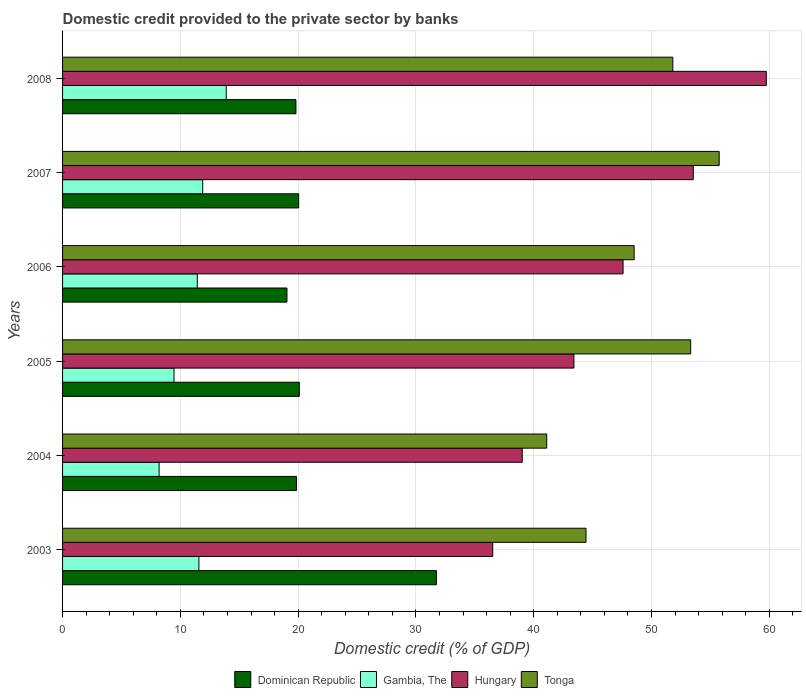How many different coloured bars are there?
Ensure brevity in your answer.  4. How many groups of bars are there?
Your response must be concise. 6. Are the number of bars per tick equal to the number of legend labels?
Keep it short and to the point. Yes. Are the number of bars on each tick of the Y-axis equal?
Your response must be concise. Yes. How many bars are there on the 1st tick from the bottom?
Your answer should be compact. 4. In how many cases, is the number of bars for a given year not equal to the number of legend labels?
Make the answer very short. 0. What is the domestic credit provided to the private sector by banks in Hungary in 2006?
Ensure brevity in your answer.  47.59. Across all years, what is the maximum domestic credit provided to the private sector by banks in Tonga?
Provide a short and direct response. 55.75. Across all years, what is the minimum domestic credit provided to the private sector by banks in Gambia, The?
Your answer should be compact. 8.2. In which year was the domestic credit provided to the private sector by banks in Gambia, The minimum?
Your response must be concise. 2004. What is the total domestic credit provided to the private sector by banks in Hungary in the graph?
Your answer should be compact. 279.86. What is the difference between the domestic credit provided to the private sector by banks in Hungary in 2006 and that in 2007?
Give a very brief answer. -5.96. What is the difference between the domestic credit provided to the private sector by banks in Gambia, The in 2005 and the domestic credit provided to the private sector by banks in Hungary in 2007?
Ensure brevity in your answer.  -44.09. What is the average domestic credit provided to the private sector by banks in Hungary per year?
Your answer should be very brief. 46.64. In the year 2008, what is the difference between the domestic credit provided to the private sector by banks in Hungary and domestic credit provided to the private sector by banks in Gambia, The?
Ensure brevity in your answer.  45.86. In how many years, is the domestic credit provided to the private sector by banks in Hungary greater than 42 %?
Give a very brief answer. 4. What is the ratio of the domestic credit provided to the private sector by banks in Dominican Republic in 2007 to that in 2008?
Make the answer very short. 1.01. Is the domestic credit provided to the private sector by banks in Gambia, The in 2003 less than that in 2004?
Offer a terse response. No. What is the difference between the highest and the second highest domestic credit provided to the private sector by banks in Tonga?
Your answer should be compact. 2.42. What is the difference between the highest and the lowest domestic credit provided to the private sector by banks in Hungary?
Your answer should be compact. 23.23. In how many years, is the domestic credit provided to the private sector by banks in Tonga greater than the average domestic credit provided to the private sector by banks in Tonga taken over all years?
Your answer should be very brief. 3. Is it the case that in every year, the sum of the domestic credit provided to the private sector by banks in Hungary and domestic credit provided to the private sector by banks in Gambia, The is greater than the sum of domestic credit provided to the private sector by banks in Dominican Republic and domestic credit provided to the private sector by banks in Tonga?
Provide a succinct answer. Yes. What does the 2nd bar from the top in 2003 represents?
Your answer should be compact. Hungary. What does the 2nd bar from the bottom in 2005 represents?
Provide a succinct answer. Gambia, The. How many years are there in the graph?
Offer a terse response. 6. Are the values on the major ticks of X-axis written in scientific E-notation?
Give a very brief answer. No. Does the graph contain grids?
Offer a very short reply. Yes. How many legend labels are there?
Your answer should be compact. 4. What is the title of the graph?
Your answer should be very brief. Domestic credit provided to the private sector by banks. Does "Zambia" appear as one of the legend labels in the graph?
Keep it short and to the point. No. What is the label or title of the X-axis?
Make the answer very short. Domestic credit (% of GDP). What is the Domestic credit (% of GDP) of Dominican Republic in 2003?
Provide a short and direct response. 31.74. What is the Domestic credit (% of GDP) of Gambia, The in 2003?
Provide a short and direct response. 11.58. What is the Domestic credit (% of GDP) in Hungary in 2003?
Your answer should be compact. 36.52. What is the Domestic credit (% of GDP) in Tonga in 2003?
Your answer should be very brief. 44.44. What is the Domestic credit (% of GDP) of Dominican Republic in 2004?
Keep it short and to the point. 19.86. What is the Domestic credit (% of GDP) in Gambia, The in 2004?
Give a very brief answer. 8.2. What is the Domestic credit (% of GDP) of Hungary in 2004?
Your answer should be very brief. 39.03. What is the Domestic credit (% of GDP) in Tonga in 2004?
Ensure brevity in your answer.  41.11. What is the Domestic credit (% of GDP) in Dominican Republic in 2005?
Keep it short and to the point. 20.1. What is the Domestic credit (% of GDP) of Gambia, The in 2005?
Offer a terse response. 9.46. What is the Domestic credit (% of GDP) of Hungary in 2005?
Offer a very short reply. 43.42. What is the Domestic credit (% of GDP) of Tonga in 2005?
Your answer should be compact. 53.33. What is the Domestic credit (% of GDP) of Dominican Republic in 2006?
Make the answer very short. 19.05. What is the Domestic credit (% of GDP) in Gambia, The in 2006?
Ensure brevity in your answer.  11.44. What is the Domestic credit (% of GDP) of Hungary in 2006?
Give a very brief answer. 47.59. What is the Domestic credit (% of GDP) in Tonga in 2006?
Provide a succinct answer. 48.53. What is the Domestic credit (% of GDP) in Dominican Republic in 2007?
Offer a terse response. 20.05. What is the Domestic credit (% of GDP) of Gambia, The in 2007?
Provide a succinct answer. 11.9. What is the Domestic credit (% of GDP) of Hungary in 2007?
Provide a succinct answer. 53.55. What is the Domestic credit (% of GDP) of Tonga in 2007?
Your answer should be very brief. 55.75. What is the Domestic credit (% of GDP) in Dominican Republic in 2008?
Make the answer very short. 19.81. What is the Domestic credit (% of GDP) of Gambia, The in 2008?
Offer a terse response. 13.9. What is the Domestic credit (% of GDP) in Hungary in 2008?
Offer a terse response. 59.75. What is the Domestic credit (% of GDP) in Tonga in 2008?
Give a very brief answer. 51.81. Across all years, what is the maximum Domestic credit (% of GDP) of Dominican Republic?
Offer a very short reply. 31.74. Across all years, what is the maximum Domestic credit (% of GDP) in Gambia, The?
Offer a very short reply. 13.9. Across all years, what is the maximum Domestic credit (% of GDP) of Hungary?
Your answer should be very brief. 59.75. Across all years, what is the maximum Domestic credit (% of GDP) in Tonga?
Offer a terse response. 55.75. Across all years, what is the minimum Domestic credit (% of GDP) in Dominican Republic?
Provide a short and direct response. 19.05. Across all years, what is the minimum Domestic credit (% of GDP) in Gambia, The?
Keep it short and to the point. 8.2. Across all years, what is the minimum Domestic credit (% of GDP) of Hungary?
Provide a short and direct response. 36.52. Across all years, what is the minimum Domestic credit (% of GDP) in Tonga?
Make the answer very short. 41.11. What is the total Domestic credit (% of GDP) of Dominican Republic in the graph?
Keep it short and to the point. 130.62. What is the total Domestic credit (% of GDP) of Gambia, The in the graph?
Offer a very short reply. 66.47. What is the total Domestic credit (% of GDP) in Hungary in the graph?
Offer a terse response. 279.86. What is the total Domestic credit (% of GDP) of Tonga in the graph?
Provide a succinct answer. 294.97. What is the difference between the Domestic credit (% of GDP) in Dominican Republic in 2003 and that in 2004?
Give a very brief answer. 11.88. What is the difference between the Domestic credit (% of GDP) in Gambia, The in 2003 and that in 2004?
Ensure brevity in your answer.  3.38. What is the difference between the Domestic credit (% of GDP) in Hungary in 2003 and that in 2004?
Your answer should be compact. -2.5. What is the difference between the Domestic credit (% of GDP) of Tonga in 2003 and that in 2004?
Ensure brevity in your answer.  3.34. What is the difference between the Domestic credit (% of GDP) in Dominican Republic in 2003 and that in 2005?
Keep it short and to the point. 11.64. What is the difference between the Domestic credit (% of GDP) in Gambia, The in 2003 and that in 2005?
Your answer should be very brief. 2.11. What is the difference between the Domestic credit (% of GDP) in Hungary in 2003 and that in 2005?
Provide a short and direct response. -6.89. What is the difference between the Domestic credit (% of GDP) of Tonga in 2003 and that in 2005?
Give a very brief answer. -8.88. What is the difference between the Domestic credit (% of GDP) of Dominican Republic in 2003 and that in 2006?
Your answer should be compact. 12.69. What is the difference between the Domestic credit (% of GDP) of Gambia, The in 2003 and that in 2006?
Keep it short and to the point. 0.14. What is the difference between the Domestic credit (% of GDP) in Hungary in 2003 and that in 2006?
Your response must be concise. -11.07. What is the difference between the Domestic credit (% of GDP) in Tonga in 2003 and that in 2006?
Your answer should be very brief. -4.09. What is the difference between the Domestic credit (% of GDP) in Dominican Republic in 2003 and that in 2007?
Your answer should be very brief. 11.69. What is the difference between the Domestic credit (% of GDP) in Gambia, The in 2003 and that in 2007?
Offer a very short reply. -0.32. What is the difference between the Domestic credit (% of GDP) of Hungary in 2003 and that in 2007?
Ensure brevity in your answer.  -17.03. What is the difference between the Domestic credit (% of GDP) of Tonga in 2003 and that in 2007?
Make the answer very short. -11.31. What is the difference between the Domestic credit (% of GDP) of Dominican Republic in 2003 and that in 2008?
Your response must be concise. 11.93. What is the difference between the Domestic credit (% of GDP) in Gambia, The in 2003 and that in 2008?
Your response must be concise. -2.32. What is the difference between the Domestic credit (% of GDP) in Hungary in 2003 and that in 2008?
Ensure brevity in your answer.  -23.23. What is the difference between the Domestic credit (% of GDP) of Tonga in 2003 and that in 2008?
Provide a succinct answer. -7.37. What is the difference between the Domestic credit (% of GDP) in Dominican Republic in 2004 and that in 2005?
Give a very brief answer. -0.24. What is the difference between the Domestic credit (% of GDP) of Gambia, The in 2004 and that in 2005?
Make the answer very short. -1.26. What is the difference between the Domestic credit (% of GDP) of Hungary in 2004 and that in 2005?
Ensure brevity in your answer.  -4.39. What is the difference between the Domestic credit (% of GDP) of Tonga in 2004 and that in 2005?
Your answer should be very brief. -12.22. What is the difference between the Domestic credit (% of GDP) in Dominican Republic in 2004 and that in 2006?
Provide a short and direct response. 0.81. What is the difference between the Domestic credit (% of GDP) in Gambia, The in 2004 and that in 2006?
Your answer should be very brief. -3.24. What is the difference between the Domestic credit (% of GDP) in Hungary in 2004 and that in 2006?
Give a very brief answer. -8.56. What is the difference between the Domestic credit (% of GDP) in Tonga in 2004 and that in 2006?
Your answer should be compact. -7.42. What is the difference between the Domestic credit (% of GDP) of Dominican Republic in 2004 and that in 2007?
Offer a terse response. -0.19. What is the difference between the Domestic credit (% of GDP) of Gambia, The in 2004 and that in 2007?
Make the answer very short. -3.7. What is the difference between the Domestic credit (% of GDP) in Hungary in 2004 and that in 2007?
Keep it short and to the point. -14.52. What is the difference between the Domestic credit (% of GDP) of Tonga in 2004 and that in 2007?
Your answer should be compact. -14.64. What is the difference between the Domestic credit (% of GDP) of Dominican Republic in 2004 and that in 2008?
Your answer should be compact. 0.05. What is the difference between the Domestic credit (% of GDP) of Gambia, The in 2004 and that in 2008?
Provide a succinct answer. -5.7. What is the difference between the Domestic credit (% of GDP) of Hungary in 2004 and that in 2008?
Offer a terse response. -20.72. What is the difference between the Domestic credit (% of GDP) of Tonga in 2004 and that in 2008?
Provide a short and direct response. -10.71. What is the difference between the Domestic credit (% of GDP) of Dominican Republic in 2005 and that in 2006?
Offer a terse response. 1.05. What is the difference between the Domestic credit (% of GDP) in Gambia, The in 2005 and that in 2006?
Provide a succinct answer. -1.98. What is the difference between the Domestic credit (% of GDP) in Hungary in 2005 and that in 2006?
Your answer should be very brief. -4.17. What is the difference between the Domestic credit (% of GDP) in Tonga in 2005 and that in 2006?
Give a very brief answer. 4.8. What is the difference between the Domestic credit (% of GDP) in Dominican Republic in 2005 and that in 2007?
Offer a very short reply. 0.05. What is the difference between the Domestic credit (% of GDP) in Gambia, The in 2005 and that in 2007?
Offer a very short reply. -2.44. What is the difference between the Domestic credit (% of GDP) in Hungary in 2005 and that in 2007?
Make the answer very short. -10.14. What is the difference between the Domestic credit (% of GDP) in Tonga in 2005 and that in 2007?
Provide a succinct answer. -2.42. What is the difference between the Domestic credit (% of GDP) of Dominican Republic in 2005 and that in 2008?
Keep it short and to the point. 0.29. What is the difference between the Domestic credit (% of GDP) in Gambia, The in 2005 and that in 2008?
Your response must be concise. -4.43. What is the difference between the Domestic credit (% of GDP) of Hungary in 2005 and that in 2008?
Your answer should be compact. -16.33. What is the difference between the Domestic credit (% of GDP) in Tonga in 2005 and that in 2008?
Provide a short and direct response. 1.51. What is the difference between the Domestic credit (% of GDP) of Dominican Republic in 2006 and that in 2007?
Give a very brief answer. -1. What is the difference between the Domestic credit (% of GDP) in Gambia, The in 2006 and that in 2007?
Your answer should be very brief. -0.46. What is the difference between the Domestic credit (% of GDP) of Hungary in 2006 and that in 2007?
Keep it short and to the point. -5.96. What is the difference between the Domestic credit (% of GDP) of Tonga in 2006 and that in 2007?
Provide a short and direct response. -7.22. What is the difference between the Domestic credit (% of GDP) of Dominican Republic in 2006 and that in 2008?
Provide a short and direct response. -0.76. What is the difference between the Domestic credit (% of GDP) of Gambia, The in 2006 and that in 2008?
Provide a succinct answer. -2.46. What is the difference between the Domestic credit (% of GDP) of Hungary in 2006 and that in 2008?
Keep it short and to the point. -12.16. What is the difference between the Domestic credit (% of GDP) of Tonga in 2006 and that in 2008?
Make the answer very short. -3.28. What is the difference between the Domestic credit (% of GDP) of Dominican Republic in 2007 and that in 2008?
Give a very brief answer. 0.23. What is the difference between the Domestic credit (% of GDP) in Gambia, The in 2007 and that in 2008?
Your answer should be very brief. -2. What is the difference between the Domestic credit (% of GDP) of Hungary in 2007 and that in 2008?
Keep it short and to the point. -6.2. What is the difference between the Domestic credit (% of GDP) in Tonga in 2007 and that in 2008?
Keep it short and to the point. 3.94. What is the difference between the Domestic credit (% of GDP) of Dominican Republic in 2003 and the Domestic credit (% of GDP) of Gambia, The in 2004?
Your answer should be very brief. 23.54. What is the difference between the Domestic credit (% of GDP) in Dominican Republic in 2003 and the Domestic credit (% of GDP) in Hungary in 2004?
Your response must be concise. -7.29. What is the difference between the Domestic credit (% of GDP) of Dominican Republic in 2003 and the Domestic credit (% of GDP) of Tonga in 2004?
Your response must be concise. -9.36. What is the difference between the Domestic credit (% of GDP) of Gambia, The in 2003 and the Domestic credit (% of GDP) of Hungary in 2004?
Give a very brief answer. -27.45. What is the difference between the Domestic credit (% of GDP) in Gambia, The in 2003 and the Domestic credit (% of GDP) in Tonga in 2004?
Your answer should be very brief. -29.53. What is the difference between the Domestic credit (% of GDP) of Hungary in 2003 and the Domestic credit (% of GDP) of Tonga in 2004?
Provide a succinct answer. -4.58. What is the difference between the Domestic credit (% of GDP) in Dominican Republic in 2003 and the Domestic credit (% of GDP) in Gambia, The in 2005?
Ensure brevity in your answer.  22.28. What is the difference between the Domestic credit (% of GDP) of Dominican Republic in 2003 and the Domestic credit (% of GDP) of Hungary in 2005?
Ensure brevity in your answer.  -11.68. What is the difference between the Domestic credit (% of GDP) of Dominican Republic in 2003 and the Domestic credit (% of GDP) of Tonga in 2005?
Provide a short and direct response. -21.59. What is the difference between the Domestic credit (% of GDP) in Gambia, The in 2003 and the Domestic credit (% of GDP) in Hungary in 2005?
Offer a very short reply. -31.84. What is the difference between the Domestic credit (% of GDP) of Gambia, The in 2003 and the Domestic credit (% of GDP) of Tonga in 2005?
Your answer should be compact. -41.75. What is the difference between the Domestic credit (% of GDP) of Hungary in 2003 and the Domestic credit (% of GDP) of Tonga in 2005?
Keep it short and to the point. -16.8. What is the difference between the Domestic credit (% of GDP) in Dominican Republic in 2003 and the Domestic credit (% of GDP) in Gambia, The in 2006?
Provide a short and direct response. 20.3. What is the difference between the Domestic credit (% of GDP) of Dominican Republic in 2003 and the Domestic credit (% of GDP) of Hungary in 2006?
Provide a succinct answer. -15.85. What is the difference between the Domestic credit (% of GDP) of Dominican Republic in 2003 and the Domestic credit (% of GDP) of Tonga in 2006?
Make the answer very short. -16.79. What is the difference between the Domestic credit (% of GDP) in Gambia, The in 2003 and the Domestic credit (% of GDP) in Hungary in 2006?
Provide a succinct answer. -36.01. What is the difference between the Domestic credit (% of GDP) in Gambia, The in 2003 and the Domestic credit (% of GDP) in Tonga in 2006?
Your response must be concise. -36.95. What is the difference between the Domestic credit (% of GDP) in Hungary in 2003 and the Domestic credit (% of GDP) in Tonga in 2006?
Make the answer very short. -12.01. What is the difference between the Domestic credit (% of GDP) in Dominican Republic in 2003 and the Domestic credit (% of GDP) in Gambia, The in 2007?
Your response must be concise. 19.84. What is the difference between the Domestic credit (% of GDP) in Dominican Republic in 2003 and the Domestic credit (% of GDP) in Hungary in 2007?
Give a very brief answer. -21.81. What is the difference between the Domestic credit (% of GDP) of Dominican Republic in 2003 and the Domestic credit (% of GDP) of Tonga in 2007?
Provide a short and direct response. -24.01. What is the difference between the Domestic credit (% of GDP) in Gambia, The in 2003 and the Domestic credit (% of GDP) in Hungary in 2007?
Keep it short and to the point. -41.98. What is the difference between the Domestic credit (% of GDP) of Gambia, The in 2003 and the Domestic credit (% of GDP) of Tonga in 2007?
Your answer should be very brief. -44.17. What is the difference between the Domestic credit (% of GDP) in Hungary in 2003 and the Domestic credit (% of GDP) in Tonga in 2007?
Provide a short and direct response. -19.23. What is the difference between the Domestic credit (% of GDP) of Dominican Republic in 2003 and the Domestic credit (% of GDP) of Gambia, The in 2008?
Your answer should be compact. 17.85. What is the difference between the Domestic credit (% of GDP) in Dominican Republic in 2003 and the Domestic credit (% of GDP) in Hungary in 2008?
Provide a succinct answer. -28.01. What is the difference between the Domestic credit (% of GDP) of Dominican Republic in 2003 and the Domestic credit (% of GDP) of Tonga in 2008?
Give a very brief answer. -20.07. What is the difference between the Domestic credit (% of GDP) of Gambia, The in 2003 and the Domestic credit (% of GDP) of Hungary in 2008?
Provide a succinct answer. -48.18. What is the difference between the Domestic credit (% of GDP) in Gambia, The in 2003 and the Domestic credit (% of GDP) in Tonga in 2008?
Ensure brevity in your answer.  -40.24. What is the difference between the Domestic credit (% of GDP) in Hungary in 2003 and the Domestic credit (% of GDP) in Tonga in 2008?
Make the answer very short. -15.29. What is the difference between the Domestic credit (% of GDP) in Dominican Republic in 2004 and the Domestic credit (% of GDP) in Gambia, The in 2005?
Provide a succinct answer. 10.4. What is the difference between the Domestic credit (% of GDP) in Dominican Republic in 2004 and the Domestic credit (% of GDP) in Hungary in 2005?
Your answer should be compact. -23.55. What is the difference between the Domestic credit (% of GDP) of Dominican Republic in 2004 and the Domestic credit (% of GDP) of Tonga in 2005?
Your response must be concise. -33.47. What is the difference between the Domestic credit (% of GDP) of Gambia, The in 2004 and the Domestic credit (% of GDP) of Hungary in 2005?
Your answer should be compact. -35.22. What is the difference between the Domestic credit (% of GDP) of Gambia, The in 2004 and the Domestic credit (% of GDP) of Tonga in 2005?
Offer a very short reply. -45.13. What is the difference between the Domestic credit (% of GDP) in Hungary in 2004 and the Domestic credit (% of GDP) in Tonga in 2005?
Ensure brevity in your answer.  -14.3. What is the difference between the Domestic credit (% of GDP) of Dominican Republic in 2004 and the Domestic credit (% of GDP) of Gambia, The in 2006?
Your answer should be compact. 8.42. What is the difference between the Domestic credit (% of GDP) of Dominican Republic in 2004 and the Domestic credit (% of GDP) of Hungary in 2006?
Keep it short and to the point. -27.73. What is the difference between the Domestic credit (% of GDP) in Dominican Republic in 2004 and the Domestic credit (% of GDP) in Tonga in 2006?
Offer a terse response. -28.67. What is the difference between the Domestic credit (% of GDP) of Gambia, The in 2004 and the Domestic credit (% of GDP) of Hungary in 2006?
Offer a very short reply. -39.39. What is the difference between the Domestic credit (% of GDP) in Gambia, The in 2004 and the Domestic credit (% of GDP) in Tonga in 2006?
Your answer should be very brief. -40.33. What is the difference between the Domestic credit (% of GDP) of Hungary in 2004 and the Domestic credit (% of GDP) of Tonga in 2006?
Provide a short and direct response. -9.5. What is the difference between the Domestic credit (% of GDP) in Dominican Republic in 2004 and the Domestic credit (% of GDP) in Gambia, The in 2007?
Give a very brief answer. 7.96. What is the difference between the Domestic credit (% of GDP) of Dominican Republic in 2004 and the Domestic credit (% of GDP) of Hungary in 2007?
Give a very brief answer. -33.69. What is the difference between the Domestic credit (% of GDP) of Dominican Republic in 2004 and the Domestic credit (% of GDP) of Tonga in 2007?
Make the answer very short. -35.89. What is the difference between the Domestic credit (% of GDP) in Gambia, The in 2004 and the Domestic credit (% of GDP) in Hungary in 2007?
Make the answer very short. -45.35. What is the difference between the Domestic credit (% of GDP) in Gambia, The in 2004 and the Domestic credit (% of GDP) in Tonga in 2007?
Make the answer very short. -47.55. What is the difference between the Domestic credit (% of GDP) of Hungary in 2004 and the Domestic credit (% of GDP) of Tonga in 2007?
Ensure brevity in your answer.  -16.72. What is the difference between the Domestic credit (% of GDP) of Dominican Republic in 2004 and the Domestic credit (% of GDP) of Gambia, The in 2008?
Make the answer very short. 5.97. What is the difference between the Domestic credit (% of GDP) of Dominican Republic in 2004 and the Domestic credit (% of GDP) of Hungary in 2008?
Ensure brevity in your answer.  -39.89. What is the difference between the Domestic credit (% of GDP) of Dominican Republic in 2004 and the Domestic credit (% of GDP) of Tonga in 2008?
Provide a succinct answer. -31.95. What is the difference between the Domestic credit (% of GDP) in Gambia, The in 2004 and the Domestic credit (% of GDP) in Hungary in 2008?
Provide a succinct answer. -51.55. What is the difference between the Domestic credit (% of GDP) of Gambia, The in 2004 and the Domestic credit (% of GDP) of Tonga in 2008?
Ensure brevity in your answer.  -43.62. What is the difference between the Domestic credit (% of GDP) in Hungary in 2004 and the Domestic credit (% of GDP) in Tonga in 2008?
Keep it short and to the point. -12.78. What is the difference between the Domestic credit (% of GDP) in Dominican Republic in 2005 and the Domestic credit (% of GDP) in Gambia, The in 2006?
Ensure brevity in your answer.  8.66. What is the difference between the Domestic credit (% of GDP) in Dominican Republic in 2005 and the Domestic credit (% of GDP) in Hungary in 2006?
Your answer should be very brief. -27.49. What is the difference between the Domestic credit (% of GDP) of Dominican Republic in 2005 and the Domestic credit (% of GDP) of Tonga in 2006?
Your answer should be compact. -28.43. What is the difference between the Domestic credit (% of GDP) of Gambia, The in 2005 and the Domestic credit (% of GDP) of Hungary in 2006?
Give a very brief answer. -38.13. What is the difference between the Domestic credit (% of GDP) in Gambia, The in 2005 and the Domestic credit (% of GDP) in Tonga in 2006?
Make the answer very short. -39.07. What is the difference between the Domestic credit (% of GDP) of Hungary in 2005 and the Domestic credit (% of GDP) of Tonga in 2006?
Your answer should be compact. -5.11. What is the difference between the Domestic credit (% of GDP) in Dominican Republic in 2005 and the Domestic credit (% of GDP) in Gambia, The in 2007?
Offer a terse response. 8.2. What is the difference between the Domestic credit (% of GDP) of Dominican Republic in 2005 and the Domestic credit (% of GDP) of Hungary in 2007?
Ensure brevity in your answer.  -33.45. What is the difference between the Domestic credit (% of GDP) in Dominican Republic in 2005 and the Domestic credit (% of GDP) in Tonga in 2007?
Give a very brief answer. -35.65. What is the difference between the Domestic credit (% of GDP) of Gambia, The in 2005 and the Domestic credit (% of GDP) of Hungary in 2007?
Your answer should be compact. -44.09. What is the difference between the Domestic credit (% of GDP) in Gambia, The in 2005 and the Domestic credit (% of GDP) in Tonga in 2007?
Ensure brevity in your answer.  -46.29. What is the difference between the Domestic credit (% of GDP) in Hungary in 2005 and the Domestic credit (% of GDP) in Tonga in 2007?
Make the answer very short. -12.33. What is the difference between the Domestic credit (% of GDP) in Dominican Republic in 2005 and the Domestic credit (% of GDP) in Gambia, The in 2008?
Your answer should be compact. 6.21. What is the difference between the Domestic credit (% of GDP) of Dominican Republic in 2005 and the Domestic credit (% of GDP) of Hungary in 2008?
Offer a very short reply. -39.65. What is the difference between the Domestic credit (% of GDP) in Dominican Republic in 2005 and the Domestic credit (% of GDP) in Tonga in 2008?
Your answer should be compact. -31.71. What is the difference between the Domestic credit (% of GDP) in Gambia, The in 2005 and the Domestic credit (% of GDP) in Hungary in 2008?
Offer a very short reply. -50.29. What is the difference between the Domestic credit (% of GDP) of Gambia, The in 2005 and the Domestic credit (% of GDP) of Tonga in 2008?
Your answer should be very brief. -42.35. What is the difference between the Domestic credit (% of GDP) in Hungary in 2005 and the Domestic credit (% of GDP) in Tonga in 2008?
Offer a very short reply. -8.4. What is the difference between the Domestic credit (% of GDP) in Dominican Republic in 2006 and the Domestic credit (% of GDP) in Gambia, The in 2007?
Ensure brevity in your answer.  7.15. What is the difference between the Domestic credit (% of GDP) of Dominican Republic in 2006 and the Domestic credit (% of GDP) of Hungary in 2007?
Provide a succinct answer. -34.5. What is the difference between the Domestic credit (% of GDP) in Dominican Republic in 2006 and the Domestic credit (% of GDP) in Tonga in 2007?
Offer a very short reply. -36.7. What is the difference between the Domestic credit (% of GDP) in Gambia, The in 2006 and the Domestic credit (% of GDP) in Hungary in 2007?
Your answer should be very brief. -42.11. What is the difference between the Domestic credit (% of GDP) in Gambia, The in 2006 and the Domestic credit (% of GDP) in Tonga in 2007?
Your answer should be very brief. -44.31. What is the difference between the Domestic credit (% of GDP) of Hungary in 2006 and the Domestic credit (% of GDP) of Tonga in 2007?
Provide a succinct answer. -8.16. What is the difference between the Domestic credit (% of GDP) in Dominican Republic in 2006 and the Domestic credit (% of GDP) in Gambia, The in 2008?
Your answer should be compact. 5.16. What is the difference between the Domestic credit (% of GDP) in Dominican Republic in 2006 and the Domestic credit (% of GDP) in Hungary in 2008?
Your response must be concise. -40.7. What is the difference between the Domestic credit (% of GDP) in Dominican Republic in 2006 and the Domestic credit (% of GDP) in Tonga in 2008?
Offer a very short reply. -32.76. What is the difference between the Domestic credit (% of GDP) of Gambia, The in 2006 and the Domestic credit (% of GDP) of Hungary in 2008?
Provide a short and direct response. -48.31. What is the difference between the Domestic credit (% of GDP) in Gambia, The in 2006 and the Domestic credit (% of GDP) in Tonga in 2008?
Provide a succinct answer. -40.37. What is the difference between the Domestic credit (% of GDP) in Hungary in 2006 and the Domestic credit (% of GDP) in Tonga in 2008?
Ensure brevity in your answer.  -4.22. What is the difference between the Domestic credit (% of GDP) in Dominican Republic in 2007 and the Domestic credit (% of GDP) in Gambia, The in 2008?
Offer a terse response. 6.15. What is the difference between the Domestic credit (% of GDP) in Dominican Republic in 2007 and the Domestic credit (% of GDP) in Hungary in 2008?
Ensure brevity in your answer.  -39.7. What is the difference between the Domestic credit (% of GDP) in Dominican Republic in 2007 and the Domestic credit (% of GDP) in Tonga in 2008?
Your answer should be very brief. -31.77. What is the difference between the Domestic credit (% of GDP) of Gambia, The in 2007 and the Domestic credit (% of GDP) of Hungary in 2008?
Offer a terse response. -47.85. What is the difference between the Domestic credit (% of GDP) in Gambia, The in 2007 and the Domestic credit (% of GDP) in Tonga in 2008?
Offer a terse response. -39.92. What is the difference between the Domestic credit (% of GDP) of Hungary in 2007 and the Domestic credit (% of GDP) of Tonga in 2008?
Give a very brief answer. 1.74. What is the average Domestic credit (% of GDP) of Dominican Republic per year?
Provide a short and direct response. 21.77. What is the average Domestic credit (% of GDP) in Gambia, The per year?
Provide a short and direct response. 11.08. What is the average Domestic credit (% of GDP) in Hungary per year?
Keep it short and to the point. 46.64. What is the average Domestic credit (% of GDP) of Tonga per year?
Provide a succinct answer. 49.16. In the year 2003, what is the difference between the Domestic credit (% of GDP) of Dominican Republic and Domestic credit (% of GDP) of Gambia, The?
Make the answer very short. 20.17. In the year 2003, what is the difference between the Domestic credit (% of GDP) of Dominican Republic and Domestic credit (% of GDP) of Hungary?
Make the answer very short. -4.78. In the year 2003, what is the difference between the Domestic credit (% of GDP) in Dominican Republic and Domestic credit (% of GDP) in Tonga?
Make the answer very short. -12.7. In the year 2003, what is the difference between the Domestic credit (% of GDP) in Gambia, The and Domestic credit (% of GDP) in Hungary?
Make the answer very short. -24.95. In the year 2003, what is the difference between the Domestic credit (% of GDP) of Gambia, The and Domestic credit (% of GDP) of Tonga?
Keep it short and to the point. -32.87. In the year 2003, what is the difference between the Domestic credit (% of GDP) of Hungary and Domestic credit (% of GDP) of Tonga?
Provide a short and direct response. -7.92. In the year 2004, what is the difference between the Domestic credit (% of GDP) of Dominican Republic and Domestic credit (% of GDP) of Gambia, The?
Make the answer very short. 11.66. In the year 2004, what is the difference between the Domestic credit (% of GDP) of Dominican Republic and Domestic credit (% of GDP) of Hungary?
Offer a terse response. -19.17. In the year 2004, what is the difference between the Domestic credit (% of GDP) in Dominican Republic and Domestic credit (% of GDP) in Tonga?
Offer a terse response. -21.24. In the year 2004, what is the difference between the Domestic credit (% of GDP) of Gambia, The and Domestic credit (% of GDP) of Hungary?
Provide a short and direct response. -30.83. In the year 2004, what is the difference between the Domestic credit (% of GDP) in Gambia, The and Domestic credit (% of GDP) in Tonga?
Your answer should be compact. -32.91. In the year 2004, what is the difference between the Domestic credit (% of GDP) in Hungary and Domestic credit (% of GDP) in Tonga?
Your answer should be very brief. -2.08. In the year 2005, what is the difference between the Domestic credit (% of GDP) of Dominican Republic and Domestic credit (% of GDP) of Gambia, The?
Your answer should be compact. 10.64. In the year 2005, what is the difference between the Domestic credit (% of GDP) of Dominican Republic and Domestic credit (% of GDP) of Hungary?
Your answer should be compact. -23.31. In the year 2005, what is the difference between the Domestic credit (% of GDP) in Dominican Republic and Domestic credit (% of GDP) in Tonga?
Make the answer very short. -33.23. In the year 2005, what is the difference between the Domestic credit (% of GDP) in Gambia, The and Domestic credit (% of GDP) in Hungary?
Provide a short and direct response. -33.95. In the year 2005, what is the difference between the Domestic credit (% of GDP) in Gambia, The and Domestic credit (% of GDP) in Tonga?
Your response must be concise. -43.87. In the year 2005, what is the difference between the Domestic credit (% of GDP) in Hungary and Domestic credit (% of GDP) in Tonga?
Keep it short and to the point. -9.91. In the year 2006, what is the difference between the Domestic credit (% of GDP) in Dominican Republic and Domestic credit (% of GDP) in Gambia, The?
Ensure brevity in your answer.  7.61. In the year 2006, what is the difference between the Domestic credit (% of GDP) of Dominican Republic and Domestic credit (% of GDP) of Hungary?
Give a very brief answer. -28.54. In the year 2006, what is the difference between the Domestic credit (% of GDP) of Dominican Republic and Domestic credit (% of GDP) of Tonga?
Give a very brief answer. -29.48. In the year 2006, what is the difference between the Domestic credit (% of GDP) of Gambia, The and Domestic credit (% of GDP) of Hungary?
Provide a short and direct response. -36.15. In the year 2006, what is the difference between the Domestic credit (% of GDP) of Gambia, The and Domestic credit (% of GDP) of Tonga?
Offer a terse response. -37.09. In the year 2006, what is the difference between the Domestic credit (% of GDP) of Hungary and Domestic credit (% of GDP) of Tonga?
Offer a terse response. -0.94. In the year 2007, what is the difference between the Domestic credit (% of GDP) of Dominican Republic and Domestic credit (% of GDP) of Gambia, The?
Provide a short and direct response. 8.15. In the year 2007, what is the difference between the Domestic credit (% of GDP) of Dominican Republic and Domestic credit (% of GDP) of Hungary?
Keep it short and to the point. -33.5. In the year 2007, what is the difference between the Domestic credit (% of GDP) of Dominican Republic and Domestic credit (% of GDP) of Tonga?
Keep it short and to the point. -35.7. In the year 2007, what is the difference between the Domestic credit (% of GDP) in Gambia, The and Domestic credit (% of GDP) in Hungary?
Your answer should be compact. -41.65. In the year 2007, what is the difference between the Domestic credit (% of GDP) of Gambia, The and Domestic credit (% of GDP) of Tonga?
Your answer should be compact. -43.85. In the year 2007, what is the difference between the Domestic credit (% of GDP) of Hungary and Domestic credit (% of GDP) of Tonga?
Offer a terse response. -2.2. In the year 2008, what is the difference between the Domestic credit (% of GDP) of Dominican Republic and Domestic credit (% of GDP) of Gambia, The?
Offer a very short reply. 5.92. In the year 2008, what is the difference between the Domestic credit (% of GDP) of Dominican Republic and Domestic credit (% of GDP) of Hungary?
Make the answer very short. -39.94. In the year 2008, what is the difference between the Domestic credit (% of GDP) in Dominican Republic and Domestic credit (% of GDP) in Tonga?
Offer a terse response. -32. In the year 2008, what is the difference between the Domestic credit (% of GDP) of Gambia, The and Domestic credit (% of GDP) of Hungary?
Make the answer very short. -45.85. In the year 2008, what is the difference between the Domestic credit (% of GDP) in Gambia, The and Domestic credit (% of GDP) in Tonga?
Your answer should be compact. -37.92. In the year 2008, what is the difference between the Domestic credit (% of GDP) of Hungary and Domestic credit (% of GDP) of Tonga?
Your answer should be compact. 7.94. What is the ratio of the Domestic credit (% of GDP) in Dominican Republic in 2003 to that in 2004?
Offer a very short reply. 1.6. What is the ratio of the Domestic credit (% of GDP) of Gambia, The in 2003 to that in 2004?
Ensure brevity in your answer.  1.41. What is the ratio of the Domestic credit (% of GDP) in Hungary in 2003 to that in 2004?
Provide a succinct answer. 0.94. What is the ratio of the Domestic credit (% of GDP) in Tonga in 2003 to that in 2004?
Give a very brief answer. 1.08. What is the ratio of the Domestic credit (% of GDP) of Dominican Republic in 2003 to that in 2005?
Your answer should be compact. 1.58. What is the ratio of the Domestic credit (% of GDP) in Gambia, The in 2003 to that in 2005?
Give a very brief answer. 1.22. What is the ratio of the Domestic credit (% of GDP) in Hungary in 2003 to that in 2005?
Make the answer very short. 0.84. What is the ratio of the Domestic credit (% of GDP) of Tonga in 2003 to that in 2005?
Ensure brevity in your answer.  0.83. What is the ratio of the Domestic credit (% of GDP) of Dominican Republic in 2003 to that in 2006?
Give a very brief answer. 1.67. What is the ratio of the Domestic credit (% of GDP) in Gambia, The in 2003 to that in 2006?
Offer a terse response. 1.01. What is the ratio of the Domestic credit (% of GDP) of Hungary in 2003 to that in 2006?
Offer a terse response. 0.77. What is the ratio of the Domestic credit (% of GDP) of Tonga in 2003 to that in 2006?
Your answer should be very brief. 0.92. What is the ratio of the Domestic credit (% of GDP) of Dominican Republic in 2003 to that in 2007?
Ensure brevity in your answer.  1.58. What is the ratio of the Domestic credit (% of GDP) in Gambia, The in 2003 to that in 2007?
Make the answer very short. 0.97. What is the ratio of the Domestic credit (% of GDP) in Hungary in 2003 to that in 2007?
Give a very brief answer. 0.68. What is the ratio of the Domestic credit (% of GDP) of Tonga in 2003 to that in 2007?
Keep it short and to the point. 0.8. What is the ratio of the Domestic credit (% of GDP) in Dominican Republic in 2003 to that in 2008?
Your response must be concise. 1.6. What is the ratio of the Domestic credit (% of GDP) of Gambia, The in 2003 to that in 2008?
Your answer should be compact. 0.83. What is the ratio of the Domestic credit (% of GDP) of Hungary in 2003 to that in 2008?
Provide a succinct answer. 0.61. What is the ratio of the Domestic credit (% of GDP) in Tonga in 2003 to that in 2008?
Your answer should be very brief. 0.86. What is the ratio of the Domestic credit (% of GDP) of Gambia, The in 2004 to that in 2005?
Your answer should be compact. 0.87. What is the ratio of the Domestic credit (% of GDP) in Hungary in 2004 to that in 2005?
Your answer should be compact. 0.9. What is the ratio of the Domestic credit (% of GDP) of Tonga in 2004 to that in 2005?
Keep it short and to the point. 0.77. What is the ratio of the Domestic credit (% of GDP) of Dominican Republic in 2004 to that in 2006?
Offer a terse response. 1.04. What is the ratio of the Domestic credit (% of GDP) of Gambia, The in 2004 to that in 2006?
Make the answer very short. 0.72. What is the ratio of the Domestic credit (% of GDP) of Hungary in 2004 to that in 2006?
Offer a terse response. 0.82. What is the ratio of the Domestic credit (% of GDP) of Tonga in 2004 to that in 2006?
Provide a succinct answer. 0.85. What is the ratio of the Domestic credit (% of GDP) of Gambia, The in 2004 to that in 2007?
Your answer should be very brief. 0.69. What is the ratio of the Domestic credit (% of GDP) of Hungary in 2004 to that in 2007?
Make the answer very short. 0.73. What is the ratio of the Domestic credit (% of GDP) in Tonga in 2004 to that in 2007?
Your response must be concise. 0.74. What is the ratio of the Domestic credit (% of GDP) of Dominican Republic in 2004 to that in 2008?
Provide a succinct answer. 1. What is the ratio of the Domestic credit (% of GDP) of Gambia, The in 2004 to that in 2008?
Your answer should be compact. 0.59. What is the ratio of the Domestic credit (% of GDP) of Hungary in 2004 to that in 2008?
Ensure brevity in your answer.  0.65. What is the ratio of the Domestic credit (% of GDP) in Tonga in 2004 to that in 2008?
Ensure brevity in your answer.  0.79. What is the ratio of the Domestic credit (% of GDP) of Dominican Republic in 2005 to that in 2006?
Provide a succinct answer. 1.06. What is the ratio of the Domestic credit (% of GDP) of Gambia, The in 2005 to that in 2006?
Your answer should be compact. 0.83. What is the ratio of the Domestic credit (% of GDP) of Hungary in 2005 to that in 2006?
Your answer should be very brief. 0.91. What is the ratio of the Domestic credit (% of GDP) of Tonga in 2005 to that in 2006?
Your answer should be compact. 1.1. What is the ratio of the Domestic credit (% of GDP) in Gambia, The in 2005 to that in 2007?
Offer a terse response. 0.8. What is the ratio of the Domestic credit (% of GDP) in Hungary in 2005 to that in 2007?
Give a very brief answer. 0.81. What is the ratio of the Domestic credit (% of GDP) in Tonga in 2005 to that in 2007?
Your answer should be very brief. 0.96. What is the ratio of the Domestic credit (% of GDP) in Dominican Republic in 2005 to that in 2008?
Give a very brief answer. 1.01. What is the ratio of the Domestic credit (% of GDP) in Gambia, The in 2005 to that in 2008?
Offer a very short reply. 0.68. What is the ratio of the Domestic credit (% of GDP) in Hungary in 2005 to that in 2008?
Provide a short and direct response. 0.73. What is the ratio of the Domestic credit (% of GDP) in Tonga in 2005 to that in 2008?
Make the answer very short. 1.03. What is the ratio of the Domestic credit (% of GDP) in Dominican Republic in 2006 to that in 2007?
Provide a succinct answer. 0.95. What is the ratio of the Domestic credit (% of GDP) of Gambia, The in 2006 to that in 2007?
Keep it short and to the point. 0.96. What is the ratio of the Domestic credit (% of GDP) in Hungary in 2006 to that in 2007?
Your response must be concise. 0.89. What is the ratio of the Domestic credit (% of GDP) in Tonga in 2006 to that in 2007?
Your answer should be compact. 0.87. What is the ratio of the Domestic credit (% of GDP) of Dominican Republic in 2006 to that in 2008?
Ensure brevity in your answer.  0.96. What is the ratio of the Domestic credit (% of GDP) in Gambia, The in 2006 to that in 2008?
Make the answer very short. 0.82. What is the ratio of the Domestic credit (% of GDP) of Hungary in 2006 to that in 2008?
Ensure brevity in your answer.  0.8. What is the ratio of the Domestic credit (% of GDP) in Tonga in 2006 to that in 2008?
Your response must be concise. 0.94. What is the ratio of the Domestic credit (% of GDP) in Dominican Republic in 2007 to that in 2008?
Make the answer very short. 1.01. What is the ratio of the Domestic credit (% of GDP) of Gambia, The in 2007 to that in 2008?
Offer a very short reply. 0.86. What is the ratio of the Domestic credit (% of GDP) in Hungary in 2007 to that in 2008?
Your answer should be very brief. 0.9. What is the ratio of the Domestic credit (% of GDP) of Tonga in 2007 to that in 2008?
Your response must be concise. 1.08. What is the difference between the highest and the second highest Domestic credit (% of GDP) of Dominican Republic?
Keep it short and to the point. 11.64. What is the difference between the highest and the second highest Domestic credit (% of GDP) in Gambia, The?
Offer a very short reply. 2. What is the difference between the highest and the second highest Domestic credit (% of GDP) in Hungary?
Make the answer very short. 6.2. What is the difference between the highest and the second highest Domestic credit (% of GDP) in Tonga?
Offer a very short reply. 2.42. What is the difference between the highest and the lowest Domestic credit (% of GDP) in Dominican Republic?
Offer a very short reply. 12.69. What is the difference between the highest and the lowest Domestic credit (% of GDP) of Gambia, The?
Keep it short and to the point. 5.7. What is the difference between the highest and the lowest Domestic credit (% of GDP) of Hungary?
Ensure brevity in your answer.  23.23. What is the difference between the highest and the lowest Domestic credit (% of GDP) of Tonga?
Your answer should be compact. 14.64. 